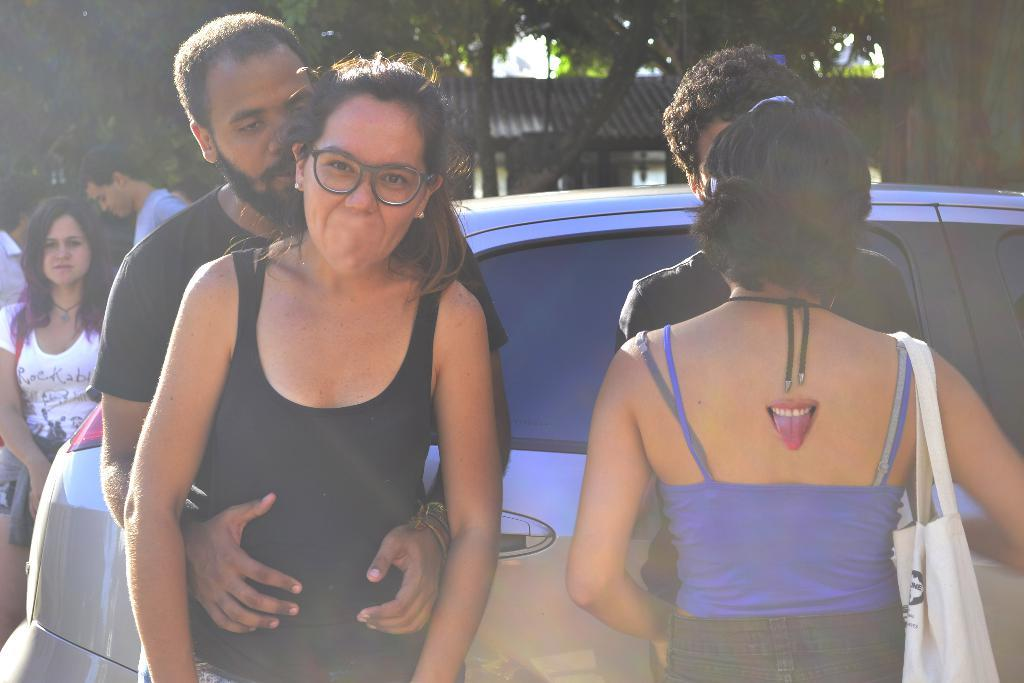What can be seen in the image? There are people standing in the image. What else is present on the right side of the image? There is a car on the right side of the image. What can be seen in the distance in the image? There are trees visible in the background of the image. How many deer can be seen in the image? There are no deer present in the image. What emotion are the people in the image expressing? The provided facts do not give information about the emotions of the people in the image. 